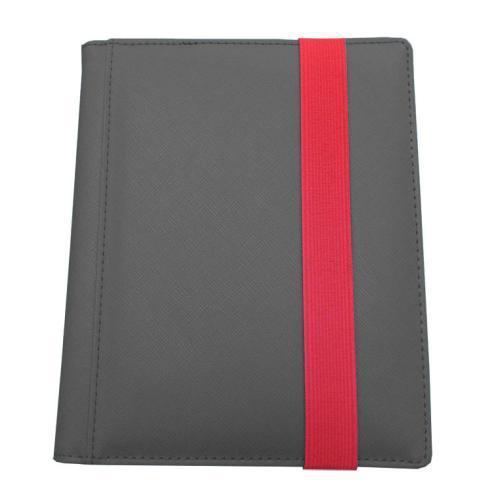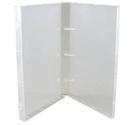The first image is the image on the left, the second image is the image on the right. For the images displayed, is the sentence "A set of three tan notebooks is arranged in a standing position." factually correct? Answer yes or no. No. 